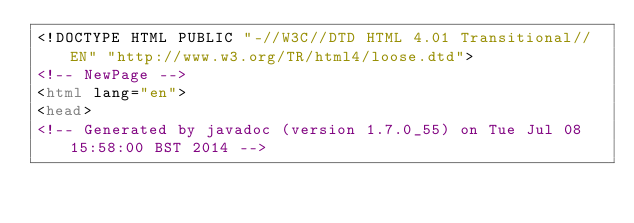<code> <loc_0><loc_0><loc_500><loc_500><_HTML_><!DOCTYPE HTML PUBLIC "-//W3C//DTD HTML 4.01 Transitional//EN" "http://www.w3.org/TR/html4/loose.dtd">
<!-- NewPage -->
<html lang="en">
<head>
<!-- Generated by javadoc (version 1.7.0_55) on Tue Jul 08 15:58:00 BST 2014 --></code> 